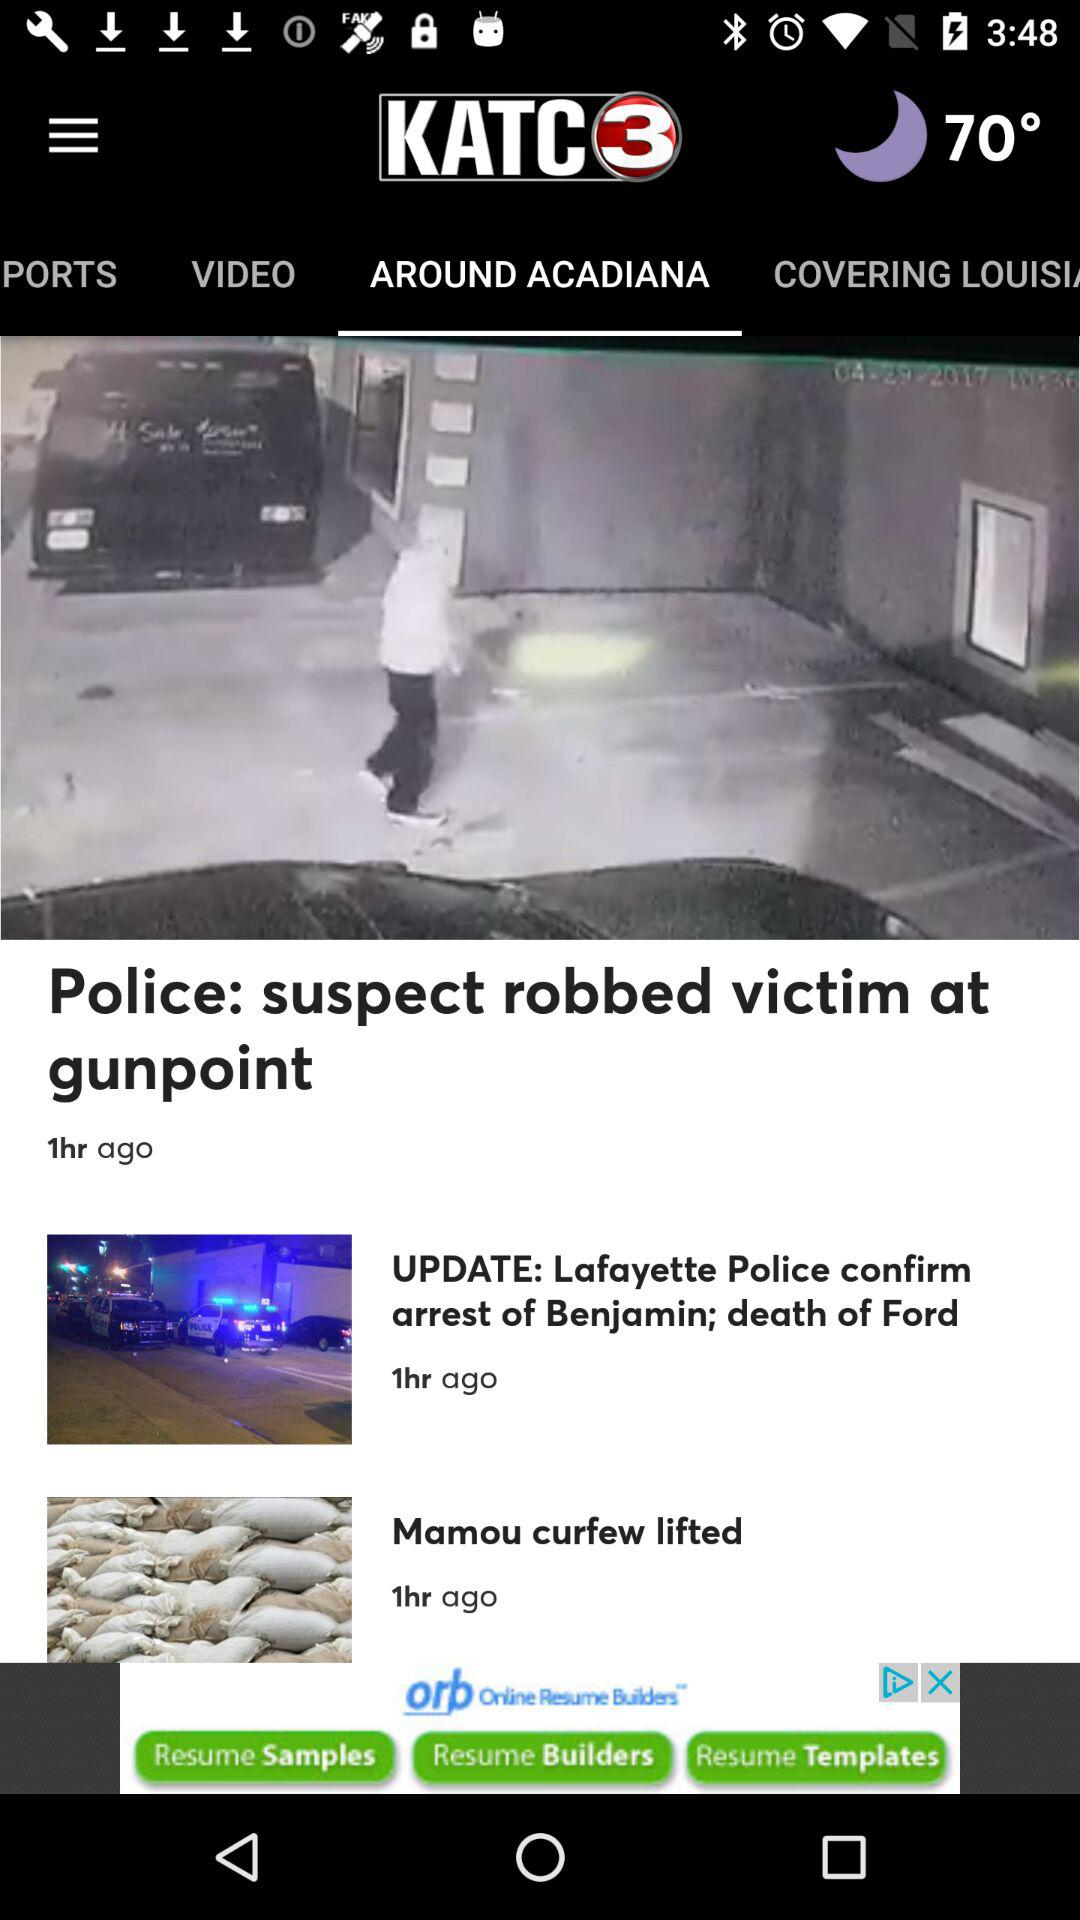What is the time duration of publishing?
When the provided information is insufficient, respond with <no answer>. <no answer> 